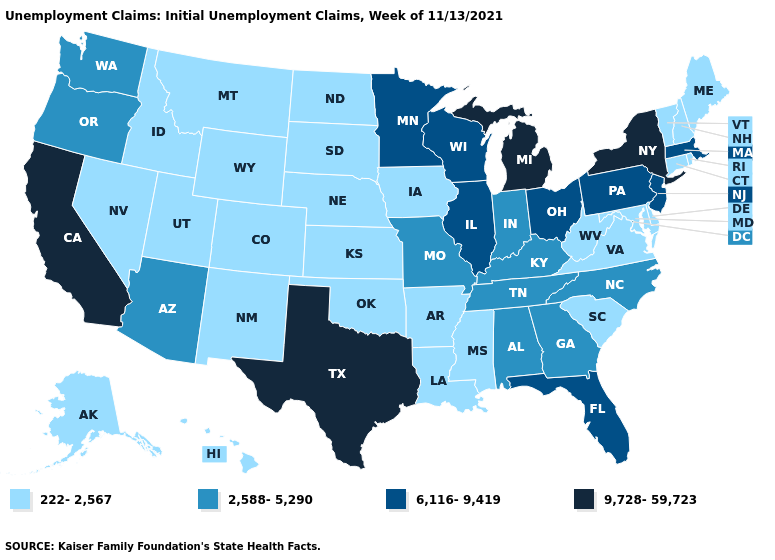Among the states that border Texas , which have the highest value?
Be succinct. Arkansas, Louisiana, New Mexico, Oklahoma. Which states have the lowest value in the USA?
Write a very short answer. Alaska, Arkansas, Colorado, Connecticut, Delaware, Hawaii, Idaho, Iowa, Kansas, Louisiana, Maine, Maryland, Mississippi, Montana, Nebraska, Nevada, New Hampshire, New Mexico, North Dakota, Oklahoma, Rhode Island, South Carolina, South Dakota, Utah, Vermont, Virginia, West Virginia, Wyoming. Does Massachusetts have the highest value in the Northeast?
Be succinct. No. What is the value of Idaho?
Be succinct. 222-2,567. Name the states that have a value in the range 9,728-59,723?
Write a very short answer. California, Michigan, New York, Texas. Name the states that have a value in the range 9,728-59,723?
Concise answer only. California, Michigan, New York, Texas. Which states have the highest value in the USA?
Give a very brief answer. California, Michigan, New York, Texas. What is the lowest value in the USA?
Short answer required. 222-2,567. What is the lowest value in states that border Rhode Island?
Keep it brief. 222-2,567. Among the states that border Pennsylvania , which have the lowest value?
Be succinct. Delaware, Maryland, West Virginia. Which states have the lowest value in the USA?
Short answer required. Alaska, Arkansas, Colorado, Connecticut, Delaware, Hawaii, Idaho, Iowa, Kansas, Louisiana, Maine, Maryland, Mississippi, Montana, Nebraska, Nevada, New Hampshire, New Mexico, North Dakota, Oklahoma, Rhode Island, South Carolina, South Dakota, Utah, Vermont, Virginia, West Virginia, Wyoming. Does Wisconsin have the same value as Illinois?
Write a very short answer. Yes. Does the first symbol in the legend represent the smallest category?
Write a very short answer. Yes. Does Utah have the lowest value in the West?
Keep it brief. Yes. 